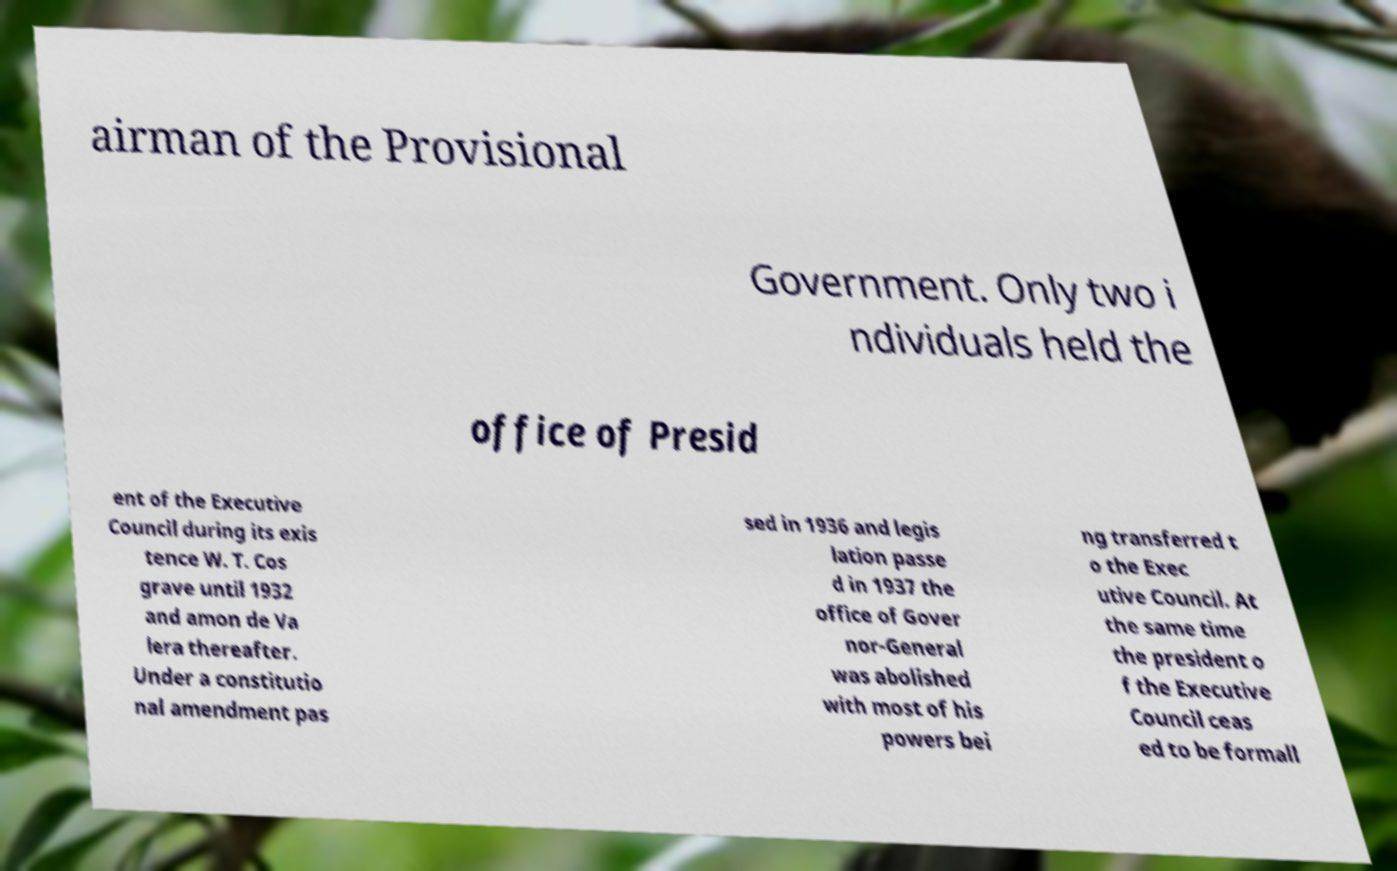What messages or text are displayed in this image? I need them in a readable, typed format. airman of the Provisional Government. Only two i ndividuals held the office of Presid ent of the Executive Council during its exis tence W. T. Cos grave until 1932 and amon de Va lera thereafter. Under a constitutio nal amendment pas sed in 1936 and legis lation passe d in 1937 the office of Gover nor-General was abolished with most of his powers bei ng transferred t o the Exec utive Council. At the same time the president o f the Executive Council ceas ed to be formall 